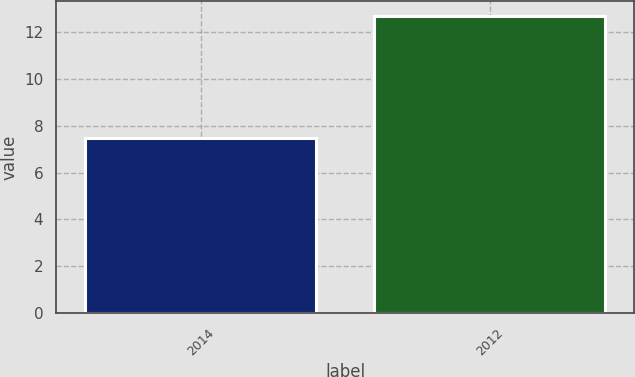<chart> <loc_0><loc_0><loc_500><loc_500><bar_chart><fcel>2014<fcel>2012<nl><fcel>7.5<fcel>12.7<nl></chart> 